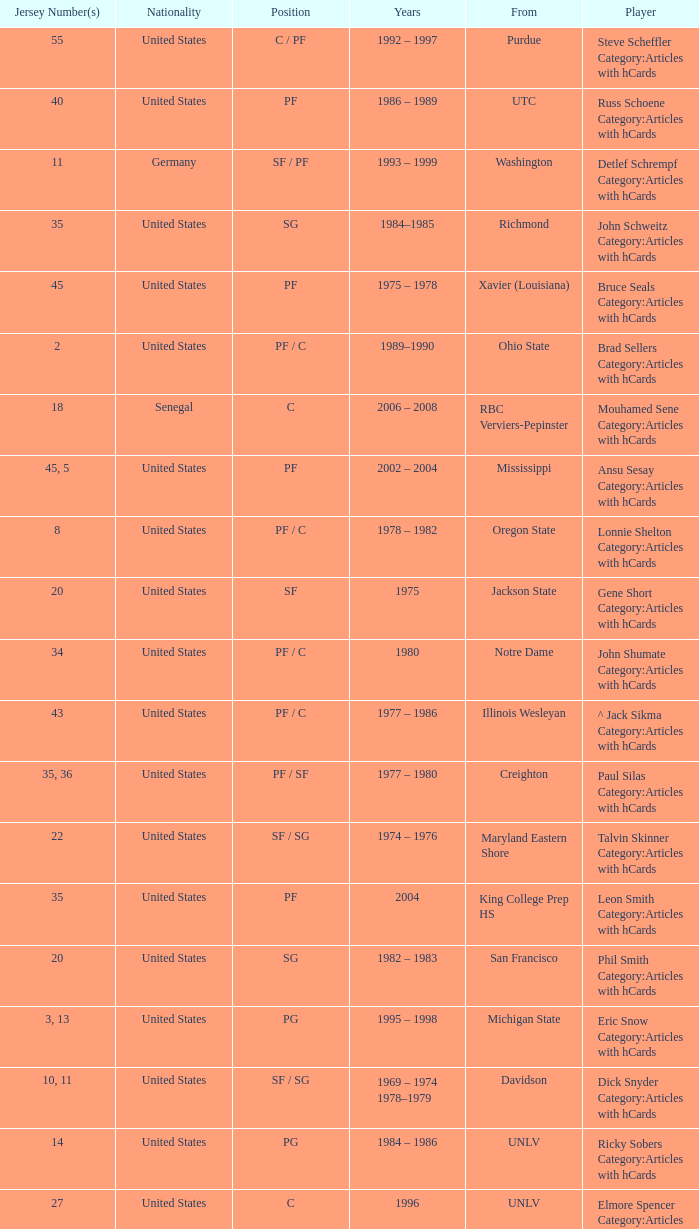What position does the player with jersey number 22 play? SF / SG. 